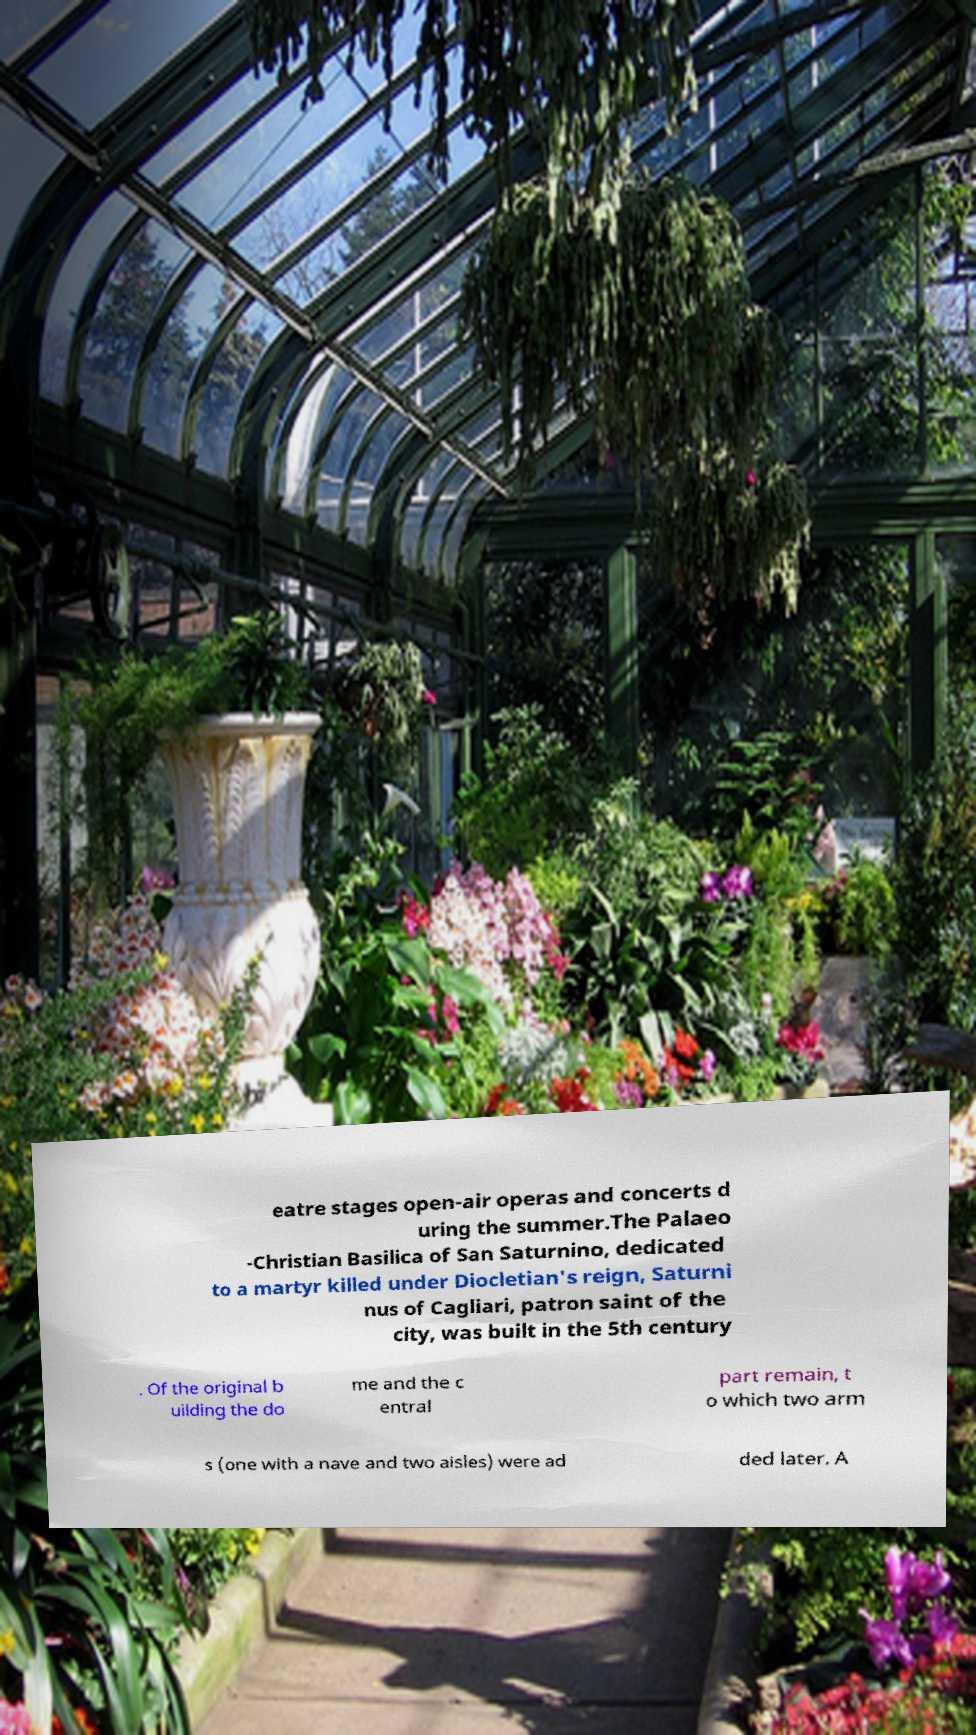There's text embedded in this image that I need extracted. Can you transcribe it verbatim? eatre stages open-air operas and concerts d uring the summer.The Palaeo -Christian Basilica of San Saturnino, dedicated to a martyr killed under Diocletian's reign, Saturni nus of Cagliari, patron saint of the city, was built in the 5th century . Of the original b uilding the do me and the c entral part remain, t o which two arm s (one with a nave and two aisles) were ad ded later. A 